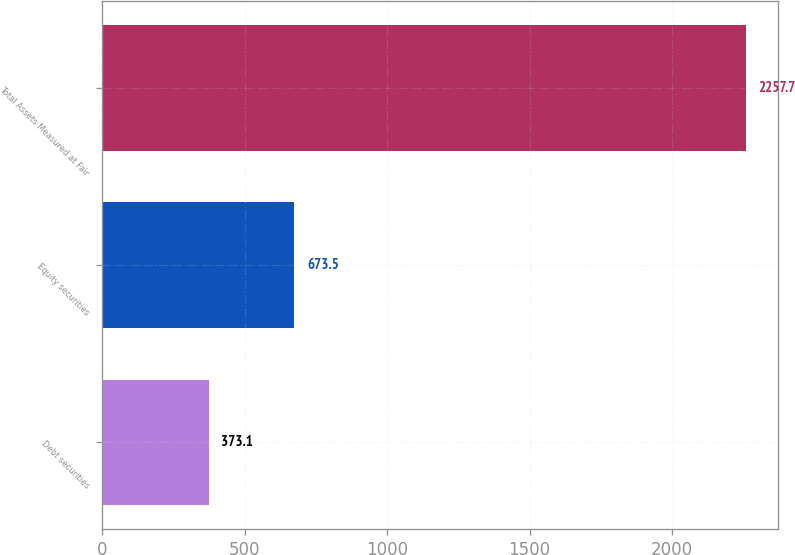Convert chart. <chart><loc_0><loc_0><loc_500><loc_500><bar_chart><fcel>Debt securities<fcel>Equity securities<fcel>Total Assets Measured at Fair<nl><fcel>373.1<fcel>673.5<fcel>2257.7<nl></chart> 